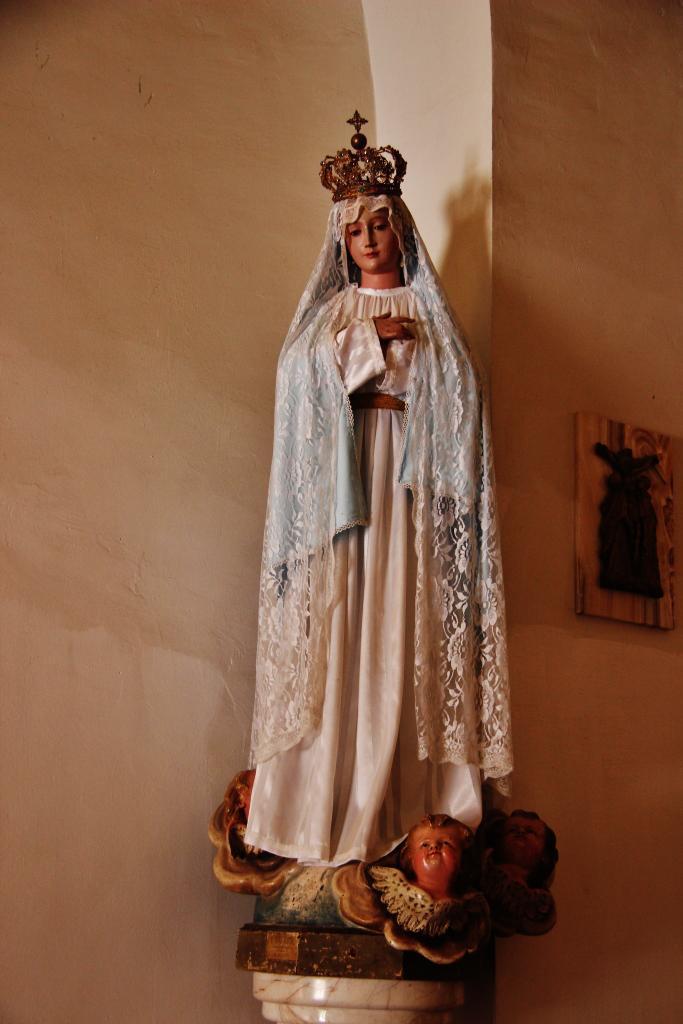Can you describe this image briefly? In the foreground of this image, there is a statue and in the background, there is a frame like an object on the wall. 